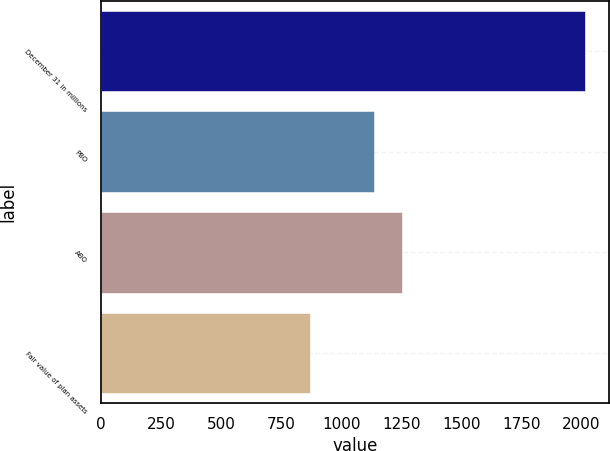<chart> <loc_0><loc_0><loc_500><loc_500><bar_chart><fcel>December 31 in millions<fcel>PBO<fcel>ABO<fcel>Fair value of plan assets<nl><fcel>2015<fcel>1136<fcel>1250.6<fcel>869<nl></chart> 